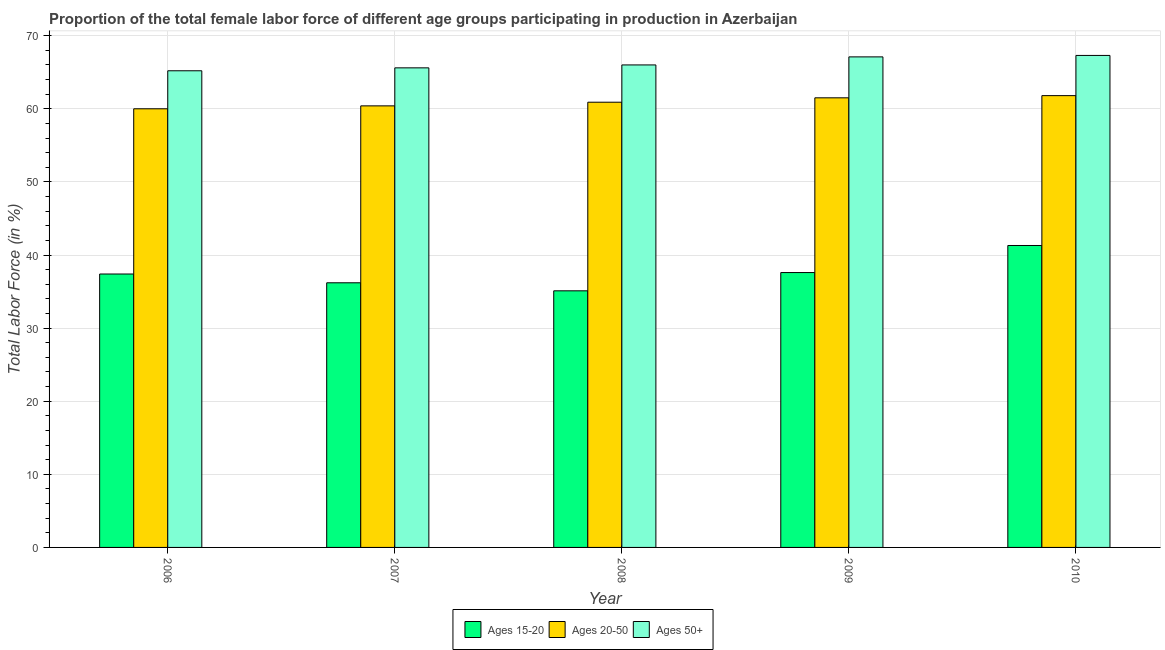How many bars are there on the 2nd tick from the right?
Keep it short and to the point. 3. What is the label of the 4th group of bars from the left?
Your response must be concise. 2009. In how many cases, is the number of bars for a given year not equal to the number of legend labels?
Your response must be concise. 0. What is the percentage of female labor force within the age group 15-20 in 2009?
Provide a short and direct response. 37.6. Across all years, what is the maximum percentage of female labor force within the age group 20-50?
Keep it short and to the point. 61.8. Across all years, what is the minimum percentage of female labor force above age 50?
Provide a short and direct response. 65.2. In which year was the percentage of female labor force within the age group 15-20 maximum?
Offer a very short reply. 2010. What is the total percentage of female labor force above age 50 in the graph?
Offer a terse response. 331.2. What is the difference between the percentage of female labor force above age 50 in 2008 and that in 2009?
Make the answer very short. -1.1. What is the difference between the percentage of female labor force within the age group 15-20 in 2006 and the percentage of female labor force above age 50 in 2009?
Provide a succinct answer. -0.2. What is the average percentage of female labor force within the age group 15-20 per year?
Your answer should be compact. 37.52. In the year 2007, what is the difference between the percentage of female labor force within the age group 15-20 and percentage of female labor force within the age group 20-50?
Offer a terse response. 0. In how many years, is the percentage of female labor force within the age group 20-50 greater than 50 %?
Offer a terse response. 5. What is the ratio of the percentage of female labor force within the age group 15-20 in 2006 to that in 2009?
Keep it short and to the point. 0.99. Is the percentage of female labor force within the age group 20-50 in 2006 less than that in 2009?
Offer a terse response. Yes. Is the difference between the percentage of female labor force within the age group 20-50 in 2007 and 2010 greater than the difference between the percentage of female labor force above age 50 in 2007 and 2010?
Give a very brief answer. No. What is the difference between the highest and the second highest percentage of female labor force above age 50?
Ensure brevity in your answer.  0.2. What is the difference between the highest and the lowest percentage of female labor force within the age group 15-20?
Provide a succinct answer. 6.2. What does the 3rd bar from the left in 2008 represents?
Ensure brevity in your answer.  Ages 50+. What does the 1st bar from the right in 2007 represents?
Provide a succinct answer. Ages 50+. Is it the case that in every year, the sum of the percentage of female labor force within the age group 15-20 and percentage of female labor force within the age group 20-50 is greater than the percentage of female labor force above age 50?
Make the answer very short. Yes. How many bars are there?
Your response must be concise. 15. How many years are there in the graph?
Make the answer very short. 5. How many legend labels are there?
Your response must be concise. 3. What is the title of the graph?
Make the answer very short. Proportion of the total female labor force of different age groups participating in production in Azerbaijan. Does "Oil sources" appear as one of the legend labels in the graph?
Offer a terse response. No. What is the Total Labor Force (in %) of Ages 15-20 in 2006?
Make the answer very short. 37.4. What is the Total Labor Force (in %) of Ages 50+ in 2006?
Your answer should be compact. 65.2. What is the Total Labor Force (in %) in Ages 15-20 in 2007?
Offer a very short reply. 36.2. What is the Total Labor Force (in %) in Ages 20-50 in 2007?
Your response must be concise. 60.4. What is the Total Labor Force (in %) of Ages 50+ in 2007?
Offer a very short reply. 65.6. What is the Total Labor Force (in %) in Ages 15-20 in 2008?
Ensure brevity in your answer.  35.1. What is the Total Labor Force (in %) in Ages 20-50 in 2008?
Your answer should be compact. 60.9. What is the Total Labor Force (in %) in Ages 15-20 in 2009?
Keep it short and to the point. 37.6. What is the Total Labor Force (in %) in Ages 20-50 in 2009?
Keep it short and to the point. 61.5. What is the Total Labor Force (in %) in Ages 50+ in 2009?
Ensure brevity in your answer.  67.1. What is the Total Labor Force (in %) of Ages 15-20 in 2010?
Your answer should be very brief. 41.3. What is the Total Labor Force (in %) of Ages 20-50 in 2010?
Your answer should be compact. 61.8. What is the Total Labor Force (in %) in Ages 50+ in 2010?
Provide a short and direct response. 67.3. Across all years, what is the maximum Total Labor Force (in %) in Ages 15-20?
Your answer should be compact. 41.3. Across all years, what is the maximum Total Labor Force (in %) of Ages 20-50?
Keep it short and to the point. 61.8. Across all years, what is the maximum Total Labor Force (in %) of Ages 50+?
Offer a very short reply. 67.3. Across all years, what is the minimum Total Labor Force (in %) in Ages 15-20?
Give a very brief answer. 35.1. Across all years, what is the minimum Total Labor Force (in %) of Ages 50+?
Provide a short and direct response. 65.2. What is the total Total Labor Force (in %) of Ages 15-20 in the graph?
Your answer should be compact. 187.6. What is the total Total Labor Force (in %) of Ages 20-50 in the graph?
Provide a short and direct response. 304.6. What is the total Total Labor Force (in %) of Ages 50+ in the graph?
Make the answer very short. 331.2. What is the difference between the Total Labor Force (in %) of Ages 15-20 in 2006 and that in 2007?
Provide a succinct answer. 1.2. What is the difference between the Total Labor Force (in %) of Ages 50+ in 2006 and that in 2007?
Offer a terse response. -0.4. What is the difference between the Total Labor Force (in %) of Ages 15-20 in 2006 and that in 2008?
Make the answer very short. 2.3. What is the difference between the Total Labor Force (in %) of Ages 50+ in 2006 and that in 2008?
Offer a very short reply. -0.8. What is the difference between the Total Labor Force (in %) in Ages 15-20 in 2006 and that in 2009?
Keep it short and to the point. -0.2. What is the difference between the Total Labor Force (in %) of Ages 20-50 in 2006 and that in 2009?
Your response must be concise. -1.5. What is the difference between the Total Labor Force (in %) of Ages 20-50 in 2006 and that in 2010?
Offer a very short reply. -1.8. What is the difference between the Total Labor Force (in %) of Ages 50+ in 2006 and that in 2010?
Make the answer very short. -2.1. What is the difference between the Total Labor Force (in %) in Ages 15-20 in 2007 and that in 2008?
Ensure brevity in your answer.  1.1. What is the difference between the Total Labor Force (in %) of Ages 50+ in 2007 and that in 2008?
Make the answer very short. -0.4. What is the difference between the Total Labor Force (in %) of Ages 15-20 in 2007 and that in 2009?
Your response must be concise. -1.4. What is the difference between the Total Labor Force (in %) in Ages 20-50 in 2008 and that in 2009?
Your answer should be compact. -0.6. What is the difference between the Total Labor Force (in %) in Ages 20-50 in 2009 and that in 2010?
Offer a very short reply. -0.3. What is the difference between the Total Labor Force (in %) of Ages 15-20 in 2006 and the Total Labor Force (in %) of Ages 50+ in 2007?
Offer a terse response. -28.2. What is the difference between the Total Labor Force (in %) of Ages 15-20 in 2006 and the Total Labor Force (in %) of Ages 20-50 in 2008?
Provide a short and direct response. -23.5. What is the difference between the Total Labor Force (in %) in Ages 15-20 in 2006 and the Total Labor Force (in %) in Ages 50+ in 2008?
Give a very brief answer. -28.6. What is the difference between the Total Labor Force (in %) in Ages 20-50 in 2006 and the Total Labor Force (in %) in Ages 50+ in 2008?
Your answer should be compact. -6. What is the difference between the Total Labor Force (in %) of Ages 15-20 in 2006 and the Total Labor Force (in %) of Ages 20-50 in 2009?
Keep it short and to the point. -24.1. What is the difference between the Total Labor Force (in %) of Ages 15-20 in 2006 and the Total Labor Force (in %) of Ages 50+ in 2009?
Give a very brief answer. -29.7. What is the difference between the Total Labor Force (in %) in Ages 20-50 in 2006 and the Total Labor Force (in %) in Ages 50+ in 2009?
Provide a succinct answer. -7.1. What is the difference between the Total Labor Force (in %) of Ages 15-20 in 2006 and the Total Labor Force (in %) of Ages 20-50 in 2010?
Give a very brief answer. -24.4. What is the difference between the Total Labor Force (in %) in Ages 15-20 in 2006 and the Total Labor Force (in %) in Ages 50+ in 2010?
Your answer should be very brief. -29.9. What is the difference between the Total Labor Force (in %) in Ages 15-20 in 2007 and the Total Labor Force (in %) in Ages 20-50 in 2008?
Offer a very short reply. -24.7. What is the difference between the Total Labor Force (in %) in Ages 15-20 in 2007 and the Total Labor Force (in %) in Ages 50+ in 2008?
Offer a terse response. -29.8. What is the difference between the Total Labor Force (in %) in Ages 15-20 in 2007 and the Total Labor Force (in %) in Ages 20-50 in 2009?
Your answer should be very brief. -25.3. What is the difference between the Total Labor Force (in %) of Ages 15-20 in 2007 and the Total Labor Force (in %) of Ages 50+ in 2009?
Your answer should be very brief. -30.9. What is the difference between the Total Labor Force (in %) of Ages 15-20 in 2007 and the Total Labor Force (in %) of Ages 20-50 in 2010?
Your answer should be compact. -25.6. What is the difference between the Total Labor Force (in %) of Ages 15-20 in 2007 and the Total Labor Force (in %) of Ages 50+ in 2010?
Your answer should be compact. -31.1. What is the difference between the Total Labor Force (in %) of Ages 20-50 in 2007 and the Total Labor Force (in %) of Ages 50+ in 2010?
Your answer should be compact. -6.9. What is the difference between the Total Labor Force (in %) in Ages 15-20 in 2008 and the Total Labor Force (in %) in Ages 20-50 in 2009?
Your answer should be compact. -26.4. What is the difference between the Total Labor Force (in %) of Ages 15-20 in 2008 and the Total Labor Force (in %) of Ages 50+ in 2009?
Provide a short and direct response. -32. What is the difference between the Total Labor Force (in %) of Ages 20-50 in 2008 and the Total Labor Force (in %) of Ages 50+ in 2009?
Provide a succinct answer. -6.2. What is the difference between the Total Labor Force (in %) of Ages 15-20 in 2008 and the Total Labor Force (in %) of Ages 20-50 in 2010?
Make the answer very short. -26.7. What is the difference between the Total Labor Force (in %) in Ages 15-20 in 2008 and the Total Labor Force (in %) in Ages 50+ in 2010?
Offer a very short reply. -32.2. What is the difference between the Total Labor Force (in %) in Ages 15-20 in 2009 and the Total Labor Force (in %) in Ages 20-50 in 2010?
Give a very brief answer. -24.2. What is the difference between the Total Labor Force (in %) of Ages 15-20 in 2009 and the Total Labor Force (in %) of Ages 50+ in 2010?
Offer a very short reply. -29.7. What is the average Total Labor Force (in %) in Ages 15-20 per year?
Your answer should be compact. 37.52. What is the average Total Labor Force (in %) of Ages 20-50 per year?
Give a very brief answer. 60.92. What is the average Total Labor Force (in %) of Ages 50+ per year?
Provide a short and direct response. 66.24. In the year 2006, what is the difference between the Total Labor Force (in %) in Ages 15-20 and Total Labor Force (in %) in Ages 20-50?
Your answer should be very brief. -22.6. In the year 2006, what is the difference between the Total Labor Force (in %) in Ages 15-20 and Total Labor Force (in %) in Ages 50+?
Ensure brevity in your answer.  -27.8. In the year 2007, what is the difference between the Total Labor Force (in %) of Ages 15-20 and Total Labor Force (in %) of Ages 20-50?
Provide a short and direct response. -24.2. In the year 2007, what is the difference between the Total Labor Force (in %) in Ages 15-20 and Total Labor Force (in %) in Ages 50+?
Provide a succinct answer. -29.4. In the year 2007, what is the difference between the Total Labor Force (in %) of Ages 20-50 and Total Labor Force (in %) of Ages 50+?
Your answer should be very brief. -5.2. In the year 2008, what is the difference between the Total Labor Force (in %) in Ages 15-20 and Total Labor Force (in %) in Ages 20-50?
Provide a succinct answer. -25.8. In the year 2008, what is the difference between the Total Labor Force (in %) in Ages 15-20 and Total Labor Force (in %) in Ages 50+?
Give a very brief answer. -30.9. In the year 2008, what is the difference between the Total Labor Force (in %) of Ages 20-50 and Total Labor Force (in %) of Ages 50+?
Provide a short and direct response. -5.1. In the year 2009, what is the difference between the Total Labor Force (in %) of Ages 15-20 and Total Labor Force (in %) of Ages 20-50?
Make the answer very short. -23.9. In the year 2009, what is the difference between the Total Labor Force (in %) in Ages 15-20 and Total Labor Force (in %) in Ages 50+?
Provide a succinct answer. -29.5. In the year 2010, what is the difference between the Total Labor Force (in %) in Ages 15-20 and Total Labor Force (in %) in Ages 20-50?
Make the answer very short. -20.5. In the year 2010, what is the difference between the Total Labor Force (in %) of Ages 15-20 and Total Labor Force (in %) of Ages 50+?
Offer a very short reply. -26. What is the ratio of the Total Labor Force (in %) in Ages 15-20 in 2006 to that in 2007?
Provide a short and direct response. 1.03. What is the ratio of the Total Labor Force (in %) in Ages 50+ in 2006 to that in 2007?
Your answer should be very brief. 0.99. What is the ratio of the Total Labor Force (in %) of Ages 15-20 in 2006 to that in 2008?
Offer a terse response. 1.07. What is the ratio of the Total Labor Force (in %) in Ages 20-50 in 2006 to that in 2008?
Offer a terse response. 0.99. What is the ratio of the Total Labor Force (in %) of Ages 50+ in 2006 to that in 2008?
Make the answer very short. 0.99. What is the ratio of the Total Labor Force (in %) in Ages 20-50 in 2006 to that in 2009?
Keep it short and to the point. 0.98. What is the ratio of the Total Labor Force (in %) in Ages 50+ in 2006 to that in 2009?
Ensure brevity in your answer.  0.97. What is the ratio of the Total Labor Force (in %) of Ages 15-20 in 2006 to that in 2010?
Make the answer very short. 0.91. What is the ratio of the Total Labor Force (in %) in Ages 20-50 in 2006 to that in 2010?
Offer a terse response. 0.97. What is the ratio of the Total Labor Force (in %) in Ages 50+ in 2006 to that in 2010?
Offer a terse response. 0.97. What is the ratio of the Total Labor Force (in %) of Ages 15-20 in 2007 to that in 2008?
Your response must be concise. 1.03. What is the ratio of the Total Labor Force (in %) of Ages 50+ in 2007 to that in 2008?
Offer a terse response. 0.99. What is the ratio of the Total Labor Force (in %) of Ages 15-20 in 2007 to that in 2009?
Give a very brief answer. 0.96. What is the ratio of the Total Labor Force (in %) in Ages 20-50 in 2007 to that in 2009?
Offer a very short reply. 0.98. What is the ratio of the Total Labor Force (in %) in Ages 50+ in 2007 to that in 2009?
Ensure brevity in your answer.  0.98. What is the ratio of the Total Labor Force (in %) of Ages 15-20 in 2007 to that in 2010?
Offer a very short reply. 0.88. What is the ratio of the Total Labor Force (in %) of Ages 20-50 in 2007 to that in 2010?
Make the answer very short. 0.98. What is the ratio of the Total Labor Force (in %) in Ages 50+ in 2007 to that in 2010?
Keep it short and to the point. 0.97. What is the ratio of the Total Labor Force (in %) of Ages 15-20 in 2008 to that in 2009?
Provide a short and direct response. 0.93. What is the ratio of the Total Labor Force (in %) of Ages 20-50 in 2008 to that in 2009?
Keep it short and to the point. 0.99. What is the ratio of the Total Labor Force (in %) in Ages 50+ in 2008 to that in 2009?
Make the answer very short. 0.98. What is the ratio of the Total Labor Force (in %) of Ages 15-20 in 2008 to that in 2010?
Offer a terse response. 0.85. What is the ratio of the Total Labor Force (in %) of Ages 20-50 in 2008 to that in 2010?
Give a very brief answer. 0.99. What is the ratio of the Total Labor Force (in %) of Ages 50+ in 2008 to that in 2010?
Make the answer very short. 0.98. What is the ratio of the Total Labor Force (in %) of Ages 15-20 in 2009 to that in 2010?
Offer a terse response. 0.91. What is the ratio of the Total Labor Force (in %) in Ages 20-50 in 2009 to that in 2010?
Provide a short and direct response. 1. What is the difference between the highest and the second highest Total Labor Force (in %) in Ages 15-20?
Give a very brief answer. 3.7. What is the difference between the highest and the second highest Total Labor Force (in %) in Ages 20-50?
Your answer should be compact. 0.3. What is the difference between the highest and the lowest Total Labor Force (in %) in Ages 15-20?
Offer a very short reply. 6.2. 